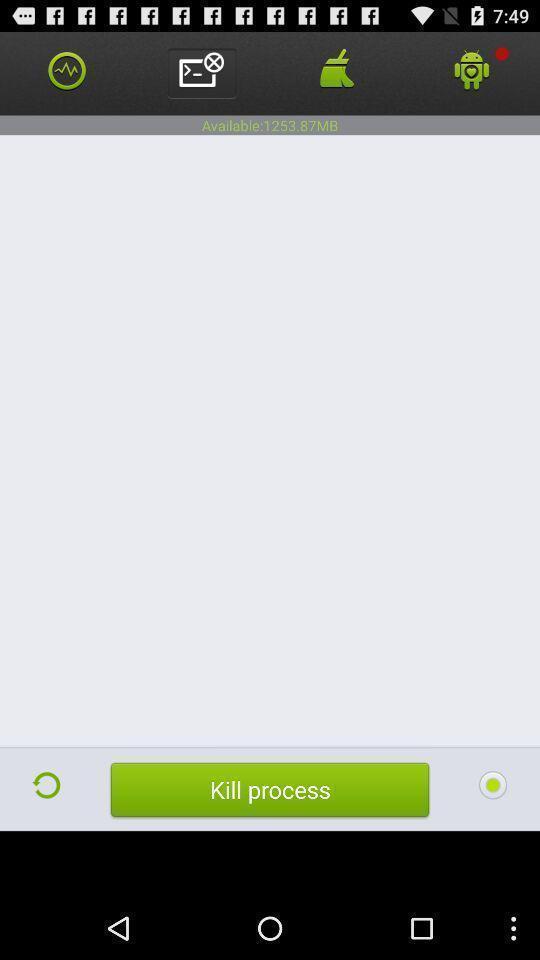What details can you identify in this image? Page displaying the multiple options. 